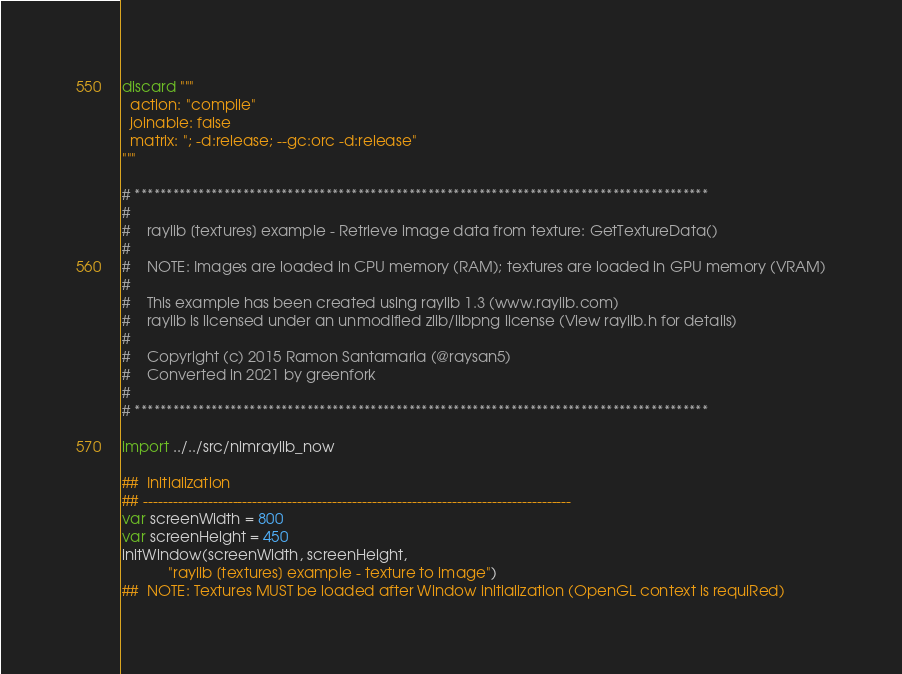Convert code to text. <code><loc_0><loc_0><loc_500><loc_500><_Nim_>discard """
  action: "compile"
  joinable: false
  matrix: "; -d:release; --gc:orc -d:release"
"""

# ******************************************************************************************
#
#    raylib [textures] example - Retrieve image data from texture: GetTextureData()
#
#    NOTE: Images are loaded in CPU memory (RAM); textures are loaded in GPU memory (VRAM)
#
#    This example has been created using raylib 1.3 (www.raylib.com)
#    raylib is licensed under an unmodified zlib/libpng license (View raylib.h for details)
#
#    Copyright (c) 2015 Ramon Santamaria (@raysan5)
#    Converted in 2021 by greenfork
#
# ******************************************************************************************

import ../../src/nimraylib_now

##  Initialization
## --------------------------------------------------------------------------------------
var screenWidth = 800
var screenHeight = 450
initWindow(screenWidth, screenHeight,
           "raylib [textures] example - texture to image")
##  NOTE: Textures MUST be loaded after Window initialization (OpenGL context is requiRed)</code> 